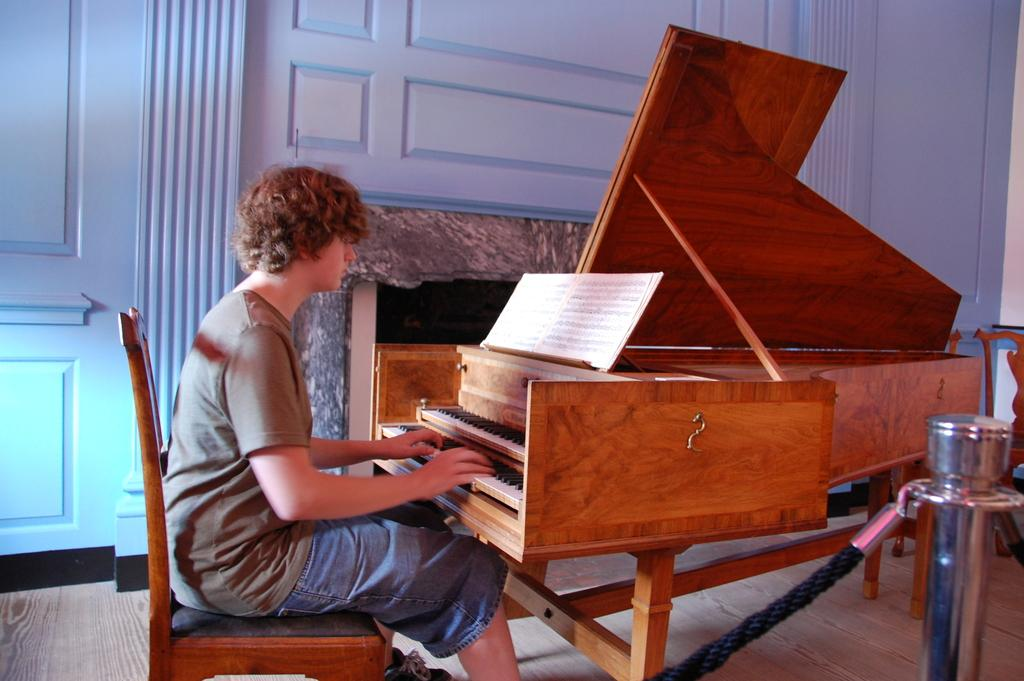What is the man in the image doing? The man is sitting on a chair and playing a piano. Can you describe the man's surroundings in the image? There is a book and a door visible in the image, as well as a rod. What might the man be using to read or learn from? The man might be using the book in the image to read or learn from. What type of basin is the man using to play the piano in the image? There is no basin present in the image, and the man is not using any basin to play the piano. 